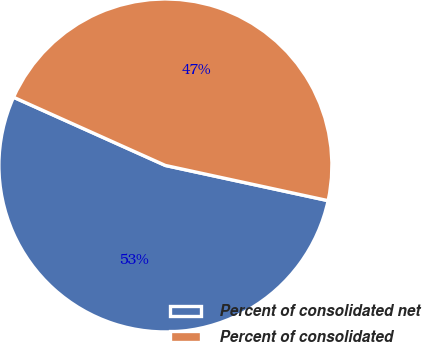<chart> <loc_0><loc_0><loc_500><loc_500><pie_chart><fcel>Percent of consolidated net<fcel>Percent of consolidated<nl><fcel>53.33%<fcel>46.67%<nl></chart> 